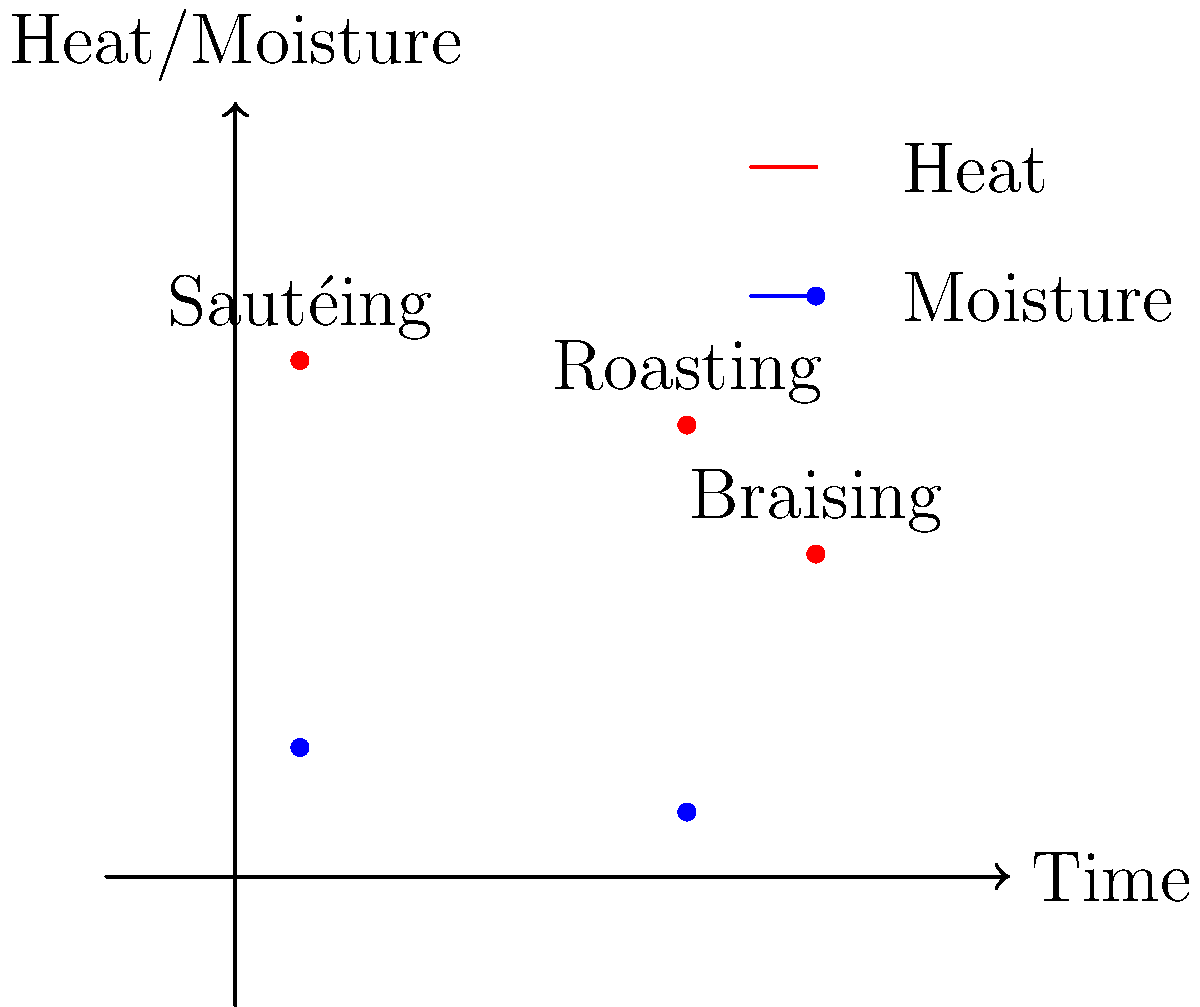Based on the graph showing the relationship between time, heat, and moisture for different cooking techniques, which technique is characterized by high heat, low moisture, and a relatively short cooking time? To answer this question, let's analyze the graph for each cooking technique:

1. Sautéing:
   - Time: Low (close to 0 on the x-axis)
   - Heat: High (red dot is high on the y-axis)
   - Moisture: Low (blue dot is low on the y-axis)

2. Braising:
   - Time: High (far right on the x-axis)
   - Heat: Medium (red dot is in the middle of the y-axis)
   - Moisture: High (blue dot is high on the y-axis)

3. Roasting:
   - Time: Medium-high (towards the right on the x-axis)
   - Heat: Medium-high (red dot is fairly high on the y-axis)
   - Moisture: Low (blue dot is low on the y-axis)

The question asks for a technique with high heat, low moisture, and relatively short cooking time. Among the three techniques shown, sautéing best fits this description:
- It has the highest heat (red dot is highest)
- It has low moisture (blue dot is low)
- It has the shortest cooking time (leftmost on the x-axis)

Therefore, the technique that matches the given characteristics is sautéing.
Answer: Sautéing 